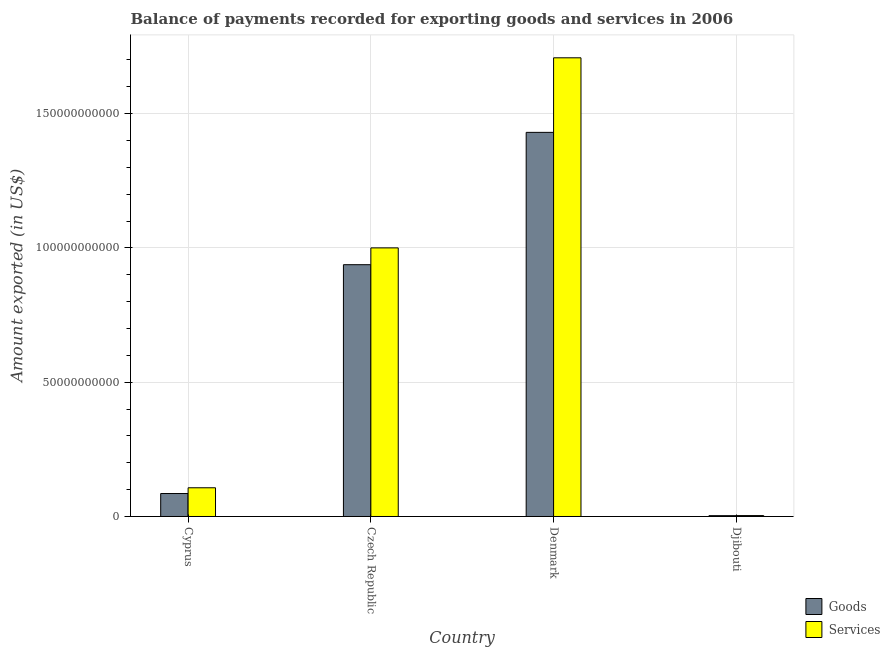How many different coloured bars are there?
Offer a very short reply. 2. How many groups of bars are there?
Provide a short and direct response. 4. Are the number of bars on each tick of the X-axis equal?
Make the answer very short. Yes. What is the label of the 4th group of bars from the left?
Provide a succinct answer. Djibouti. In how many cases, is the number of bars for a given country not equal to the number of legend labels?
Offer a terse response. 0. What is the amount of goods exported in Czech Republic?
Offer a terse response. 9.38e+1. Across all countries, what is the maximum amount of services exported?
Make the answer very short. 1.71e+11. Across all countries, what is the minimum amount of services exported?
Offer a very short reply. 3.41e+08. In which country was the amount of services exported maximum?
Provide a succinct answer. Denmark. In which country was the amount of goods exported minimum?
Provide a succinct answer. Djibouti. What is the total amount of services exported in the graph?
Your response must be concise. 2.82e+11. What is the difference between the amount of services exported in Denmark and that in Djibouti?
Your answer should be compact. 1.70e+11. What is the difference between the amount of goods exported in Djibouti and the amount of services exported in Czech Republic?
Your response must be concise. -9.97e+1. What is the average amount of goods exported per country?
Provide a succinct answer. 6.14e+1. What is the difference between the amount of services exported and amount of goods exported in Cyprus?
Provide a short and direct response. 2.14e+09. What is the ratio of the amount of services exported in Denmark to that in Djibouti?
Your answer should be compact. 500.17. What is the difference between the highest and the second highest amount of goods exported?
Provide a short and direct response. 4.93e+1. What is the difference between the highest and the lowest amount of services exported?
Give a very brief answer. 1.70e+11. In how many countries, is the amount of services exported greater than the average amount of services exported taken over all countries?
Your response must be concise. 2. What does the 1st bar from the left in Denmark represents?
Give a very brief answer. Goods. What does the 2nd bar from the right in Czech Republic represents?
Provide a short and direct response. Goods. How many bars are there?
Ensure brevity in your answer.  8. What is the difference between two consecutive major ticks on the Y-axis?
Provide a succinct answer. 5.00e+1. Does the graph contain any zero values?
Make the answer very short. No. Does the graph contain grids?
Provide a short and direct response. Yes. Where does the legend appear in the graph?
Provide a short and direct response. Bottom right. How are the legend labels stacked?
Keep it short and to the point. Vertical. What is the title of the graph?
Provide a short and direct response. Balance of payments recorded for exporting goods and services in 2006. What is the label or title of the Y-axis?
Keep it short and to the point. Amount exported (in US$). What is the Amount exported (in US$) of Goods in Cyprus?
Offer a terse response. 8.55e+09. What is the Amount exported (in US$) of Services in Cyprus?
Your answer should be very brief. 1.07e+1. What is the Amount exported (in US$) in Goods in Czech Republic?
Offer a terse response. 9.38e+1. What is the Amount exported (in US$) of Services in Czech Republic?
Provide a short and direct response. 1.00e+11. What is the Amount exported (in US$) in Goods in Denmark?
Provide a short and direct response. 1.43e+11. What is the Amount exported (in US$) in Services in Denmark?
Make the answer very short. 1.71e+11. What is the Amount exported (in US$) in Goods in Djibouti?
Ensure brevity in your answer.  3.07e+08. What is the Amount exported (in US$) of Services in Djibouti?
Keep it short and to the point. 3.41e+08. Across all countries, what is the maximum Amount exported (in US$) of Goods?
Keep it short and to the point. 1.43e+11. Across all countries, what is the maximum Amount exported (in US$) of Services?
Ensure brevity in your answer.  1.71e+11. Across all countries, what is the minimum Amount exported (in US$) of Goods?
Provide a short and direct response. 3.07e+08. Across all countries, what is the minimum Amount exported (in US$) in Services?
Your answer should be very brief. 3.41e+08. What is the total Amount exported (in US$) in Goods in the graph?
Offer a very short reply. 2.46e+11. What is the total Amount exported (in US$) of Services in the graph?
Ensure brevity in your answer.  2.82e+11. What is the difference between the Amount exported (in US$) of Goods in Cyprus and that in Czech Republic?
Keep it short and to the point. -8.52e+1. What is the difference between the Amount exported (in US$) in Services in Cyprus and that in Czech Republic?
Ensure brevity in your answer.  -8.93e+1. What is the difference between the Amount exported (in US$) in Goods in Cyprus and that in Denmark?
Your answer should be very brief. -1.34e+11. What is the difference between the Amount exported (in US$) in Services in Cyprus and that in Denmark?
Your answer should be very brief. -1.60e+11. What is the difference between the Amount exported (in US$) in Goods in Cyprus and that in Djibouti?
Make the answer very short. 8.25e+09. What is the difference between the Amount exported (in US$) of Services in Cyprus and that in Djibouti?
Your answer should be compact. 1.04e+1. What is the difference between the Amount exported (in US$) of Goods in Czech Republic and that in Denmark?
Ensure brevity in your answer.  -4.93e+1. What is the difference between the Amount exported (in US$) in Services in Czech Republic and that in Denmark?
Your answer should be very brief. -7.08e+1. What is the difference between the Amount exported (in US$) in Goods in Czech Republic and that in Djibouti?
Give a very brief answer. 9.35e+1. What is the difference between the Amount exported (in US$) of Services in Czech Republic and that in Djibouti?
Ensure brevity in your answer.  9.97e+1. What is the difference between the Amount exported (in US$) of Goods in Denmark and that in Djibouti?
Your answer should be compact. 1.43e+11. What is the difference between the Amount exported (in US$) in Services in Denmark and that in Djibouti?
Offer a very short reply. 1.70e+11. What is the difference between the Amount exported (in US$) in Goods in Cyprus and the Amount exported (in US$) in Services in Czech Republic?
Give a very brief answer. -9.15e+1. What is the difference between the Amount exported (in US$) in Goods in Cyprus and the Amount exported (in US$) in Services in Denmark?
Provide a short and direct response. -1.62e+11. What is the difference between the Amount exported (in US$) in Goods in Cyprus and the Amount exported (in US$) in Services in Djibouti?
Make the answer very short. 8.21e+09. What is the difference between the Amount exported (in US$) in Goods in Czech Republic and the Amount exported (in US$) in Services in Denmark?
Offer a terse response. -7.70e+1. What is the difference between the Amount exported (in US$) of Goods in Czech Republic and the Amount exported (in US$) of Services in Djibouti?
Offer a terse response. 9.34e+1. What is the difference between the Amount exported (in US$) in Goods in Denmark and the Amount exported (in US$) in Services in Djibouti?
Keep it short and to the point. 1.43e+11. What is the average Amount exported (in US$) in Goods per country?
Keep it short and to the point. 6.14e+1. What is the average Amount exported (in US$) of Services per country?
Give a very brief answer. 7.05e+1. What is the difference between the Amount exported (in US$) of Goods and Amount exported (in US$) of Services in Cyprus?
Provide a succinct answer. -2.14e+09. What is the difference between the Amount exported (in US$) of Goods and Amount exported (in US$) of Services in Czech Republic?
Your answer should be compact. -6.26e+09. What is the difference between the Amount exported (in US$) in Goods and Amount exported (in US$) in Services in Denmark?
Your answer should be compact. -2.78e+1. What is the difference between the Amount exported (in US$) in Goods and Amount exported (in US$) in Services in Djibouti?
Your response must be concise. -3.49e+07. What is the ratio of the Amount exported (in US$) in Goods in Cyprus to that in Czech Republic?
Your answer should be compact. 0.09. What is the ratio of the Amount exported (in US$) of Services in Cyprus to that in Czech Republic?
Your answer should be very brief. 0.11. What is the ratio of the Amount exported (in US$) of Goods in Cyprus to that in Denmark?
Ensure brevity in your answer.  0.06. What is the ratio of the Amount exported (in US$) in Services in Cyprus to that in Denmark?
Keep it short and to the point. 0.06. What is the ratio of the Amount exported (in US$) of Goods in Cyprus to that in Djibouti?
Ensure brevity in your answer.  27.89. What is the ratio of the Amount exported (in US$) in Services in Cyprus to that in Djibouti?
Ensure brevity in your answer.  31.31. What is the ratio of the Amount exported (in US$) in Goods in Czech Republic to that in Denmark?
Offer a terse response. 0.66. What is the ratio of the Amount exported (in US$) in Services in Czech Republic to that in Denmark?
Offer a terse response. 0.59. What is the ratio of the Amount exported (in US$) of Goods in Czech Republic to that in Djibouti?
Your answer should be very brief. 305.78. What is the ratio of the Amount exported (in US$) of Services in Czech Republic to that in Djibouti?
Your response must be concise. 292.9. What is the ratio of the Amount exported (in US$) in Goods in Denmark to that in Djibouti?
Your answer should be compact. 466.5. What is the ratio of the Amount exported (in US$) of Services in Denmark to that in Djibouti?
Your answer should be compact. 500.17. What is the difference between the highest and the second highest Amount exported (in US$) in Goods?
Provide a succinct answer. 4.93e+1. What is the difference between the highest and the second highest Amount exported (in US$) of Services?
Give a very brief answer. 7.08e+1. What is the difference between the highest and the lowest Amount exported (in US$) of Goods?
Give a very brief answer. 1.43e+11. What is the difference between the highest and the lowest Amount exported (in US$) of Services?
Offer a terse response. 1.70e+11. 